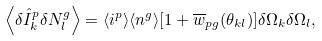Convert formula to latex. <formula><loc_0><loc_0><loc_500><loc_500>\left \langle \delta \hat { I } ^ { p } _ { k } \delta N ^ { g } _ { l } \right \rangle = \langle i ^ { p } \rangle \langle n ^ { g } \rangle [ 1 + \overline { w } _ { p g } ( \theta _ { k l } ) ] \delta \Omega _ { k } \delta \Omega _ { l } ,</formula> 